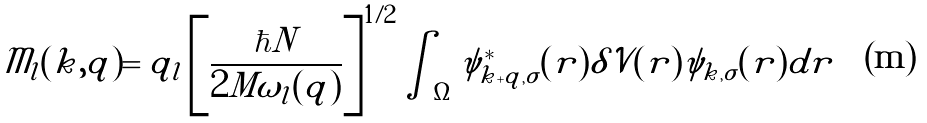Convert formula to latex. <formula><loc_0><loc_0><loc_500><loc_500>\mathcal { M } _ { l } ( { k , q } ) = \tilde { q } _ { l } \left [ \frac { \hbar { N } } { 2 M \omega _ { l } ( { q } ) } \right ] ^ { 1 / 2 } \int _ { \Omega } \psi _ { { k + q } , \sigma } ^ { * } ( { r } ) \delta \mathcal { V } ( { r } ) \psi _ { { k } , \sigma } ( { r } ) d { r }</formula> 